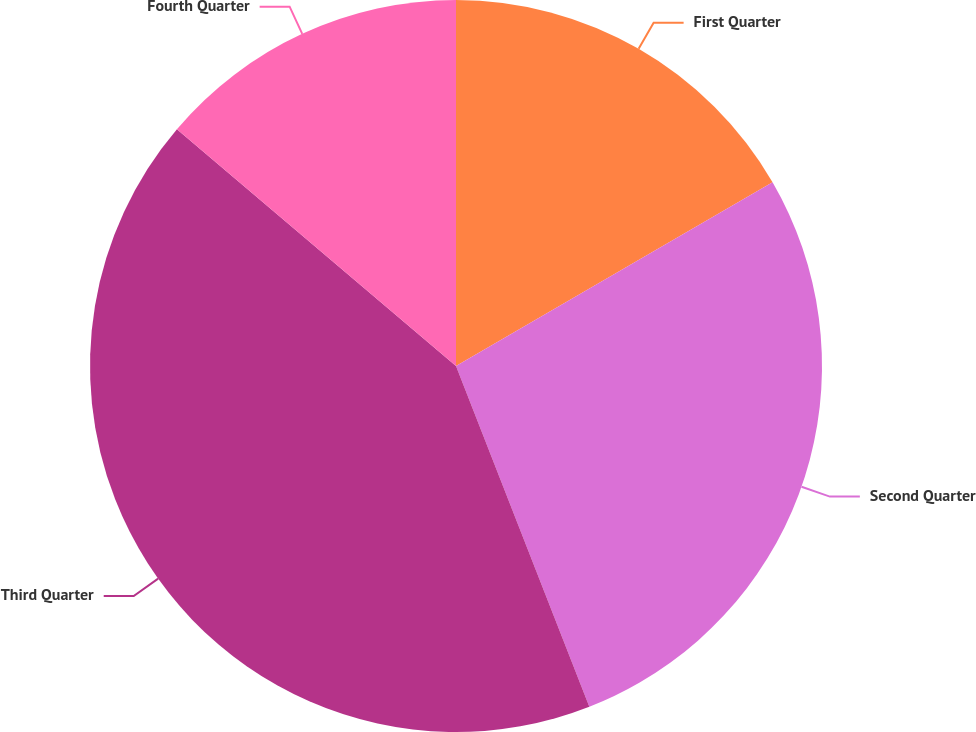Convert chart. <chart><loc_0><loc_0><loc_500><loc_500><pie_chart><fcel>First Quarter<fcel>Second Quarter<fcel>Third Quarter<fcel>Fourth Quarter<nl><fcel>16.63%<fcel>27.43%<fcel>42.13%<fcel>13.8%<nl></chart> 